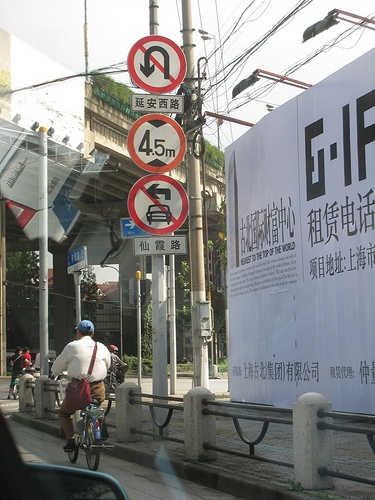Describe the objects in this image and their specific colors. I can see car in white, black, gray, and purple tones, people in white, black, darkgray, and gray tones, bicycle in white, black, gray, and blue tones, handbag in white, black, maroon, brown, and gray tones, and people in white, black, gray, and darkgray tones in this image. 